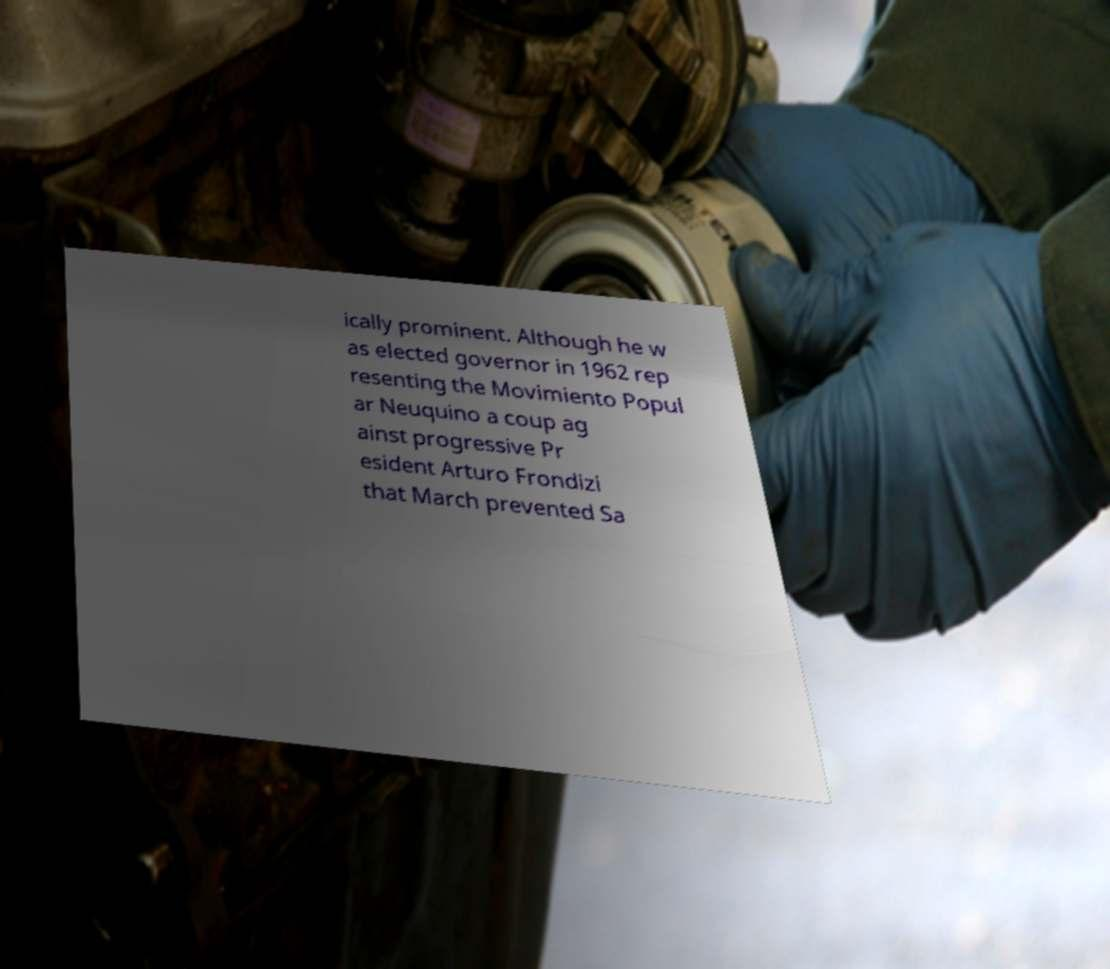I need the written content from this picture converted into text. Can you do that? ically prominent. Although he w as elected governor in 1962 rep resenting the Movimiento Popul ar Neuquino a coup ag ainst progressive Pr esident Arturo Frondizi that March prevented Sa 